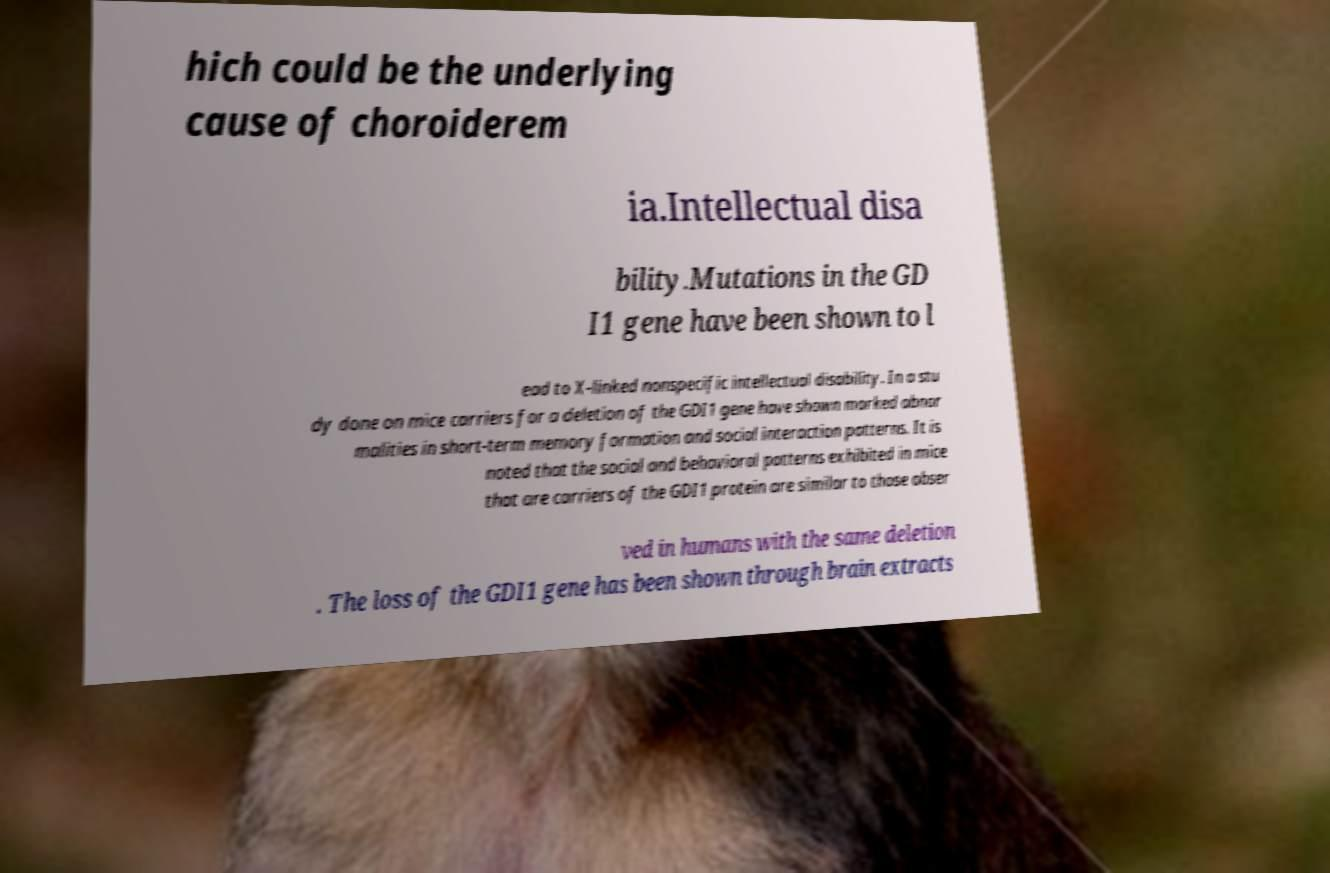Could you extract and type out the text from this image? hich could be the underlying cause of choroiderem ia.Intellectual disa bility.Mutations in the GD I1 gene have been shown to l ead to X-linked nonspecific intellectual disability. In a stu dy done on mice carriers for a deletion of the GDI1 gene have shown marked abnor malities in short-term memory formation and social interaction patterns. It is noted that the social and behavioral patterns exhibited in mice that are carriers of the GDI1 protein are similar to those obser ved in humans with the same deletion . The loss of the GDI1 gene has been shown through brain extracts 